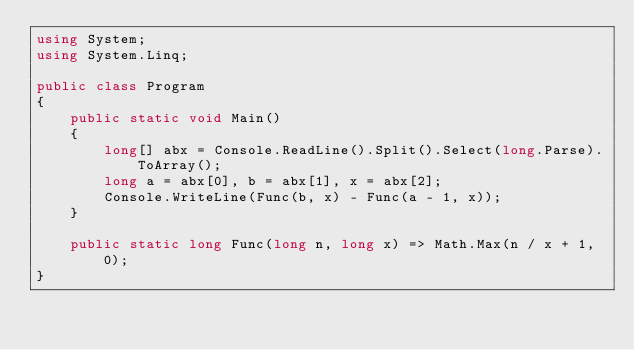Convert code to text. <code><loc_0><loc_0><loc_500><loc_500><_C#_>using System;
using System.Linq;

public class Program
{
	public static void Main()
	{
		long[] abx = Console.ReadLine().Split().Select(long.Parse).ToArray();
		long a = abx[0], b = abx[1], x = abx[2];
		Console.WriteLine(Func(b, x) - Func(a - 1, x));
	}
	
	public static long Func(long n, long x) => Math.Max(n / x + 1, 0);
}</code> 